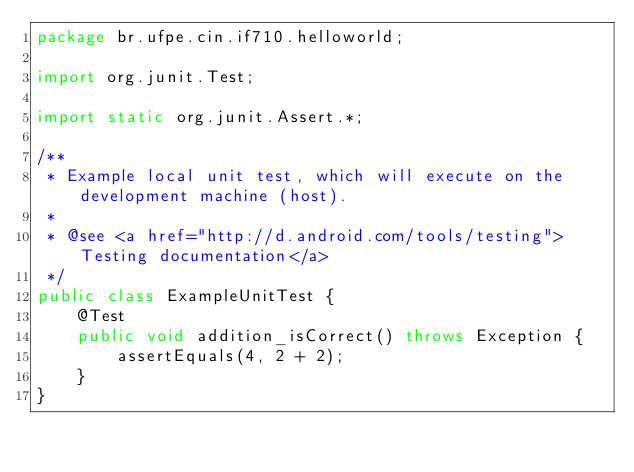<code> <loc_0><loc_0><loc_500><loc_500><_Java_>package br.ufpe.cin.if710.helloworld;

import org.junit.Test;

import static org.junit.Assert.*;

/**
 * Example local unit test, which will execute on the development machine (host).
 *
 * @see <a href="http://d.android.com/tools/testing">Testing documentation</a>
 */
public class ExampleUnitTest {
    @Test
    public void addition_isCorrect() throws Exception {
        assertEquals(4, 2 + 2);
    }
}</code> 